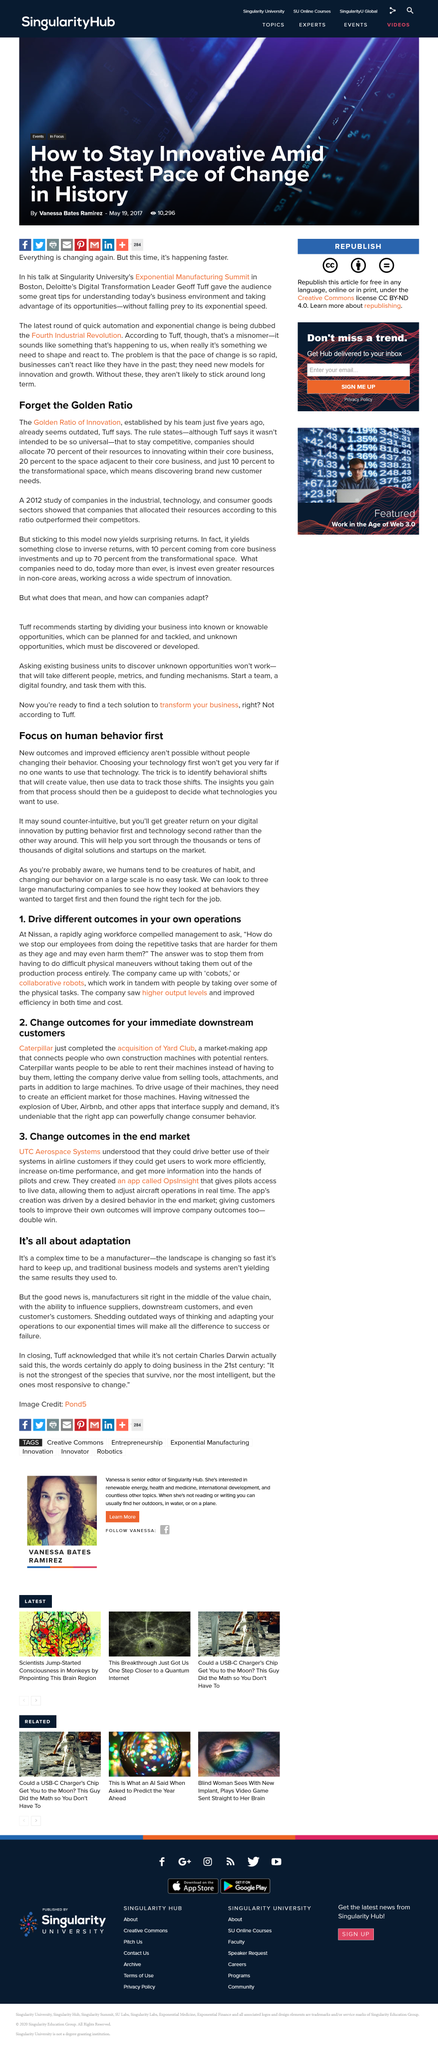Outline some significant characteristics in this image. The landscape of manufacturing is rapidly changing, and traditional business models and systems are no longer producing the same results as they used to, making it a complex time to be a manufacturer. It is the manufacturers who possess the ability to influence suppliers. After implementing cobots, the company observed an increase in output levels and enhanced efficiency in terms of both time and cost. The right app has the power to significantly alter customer behavior. The Golden Ratio of Innovation was established five years ago. 